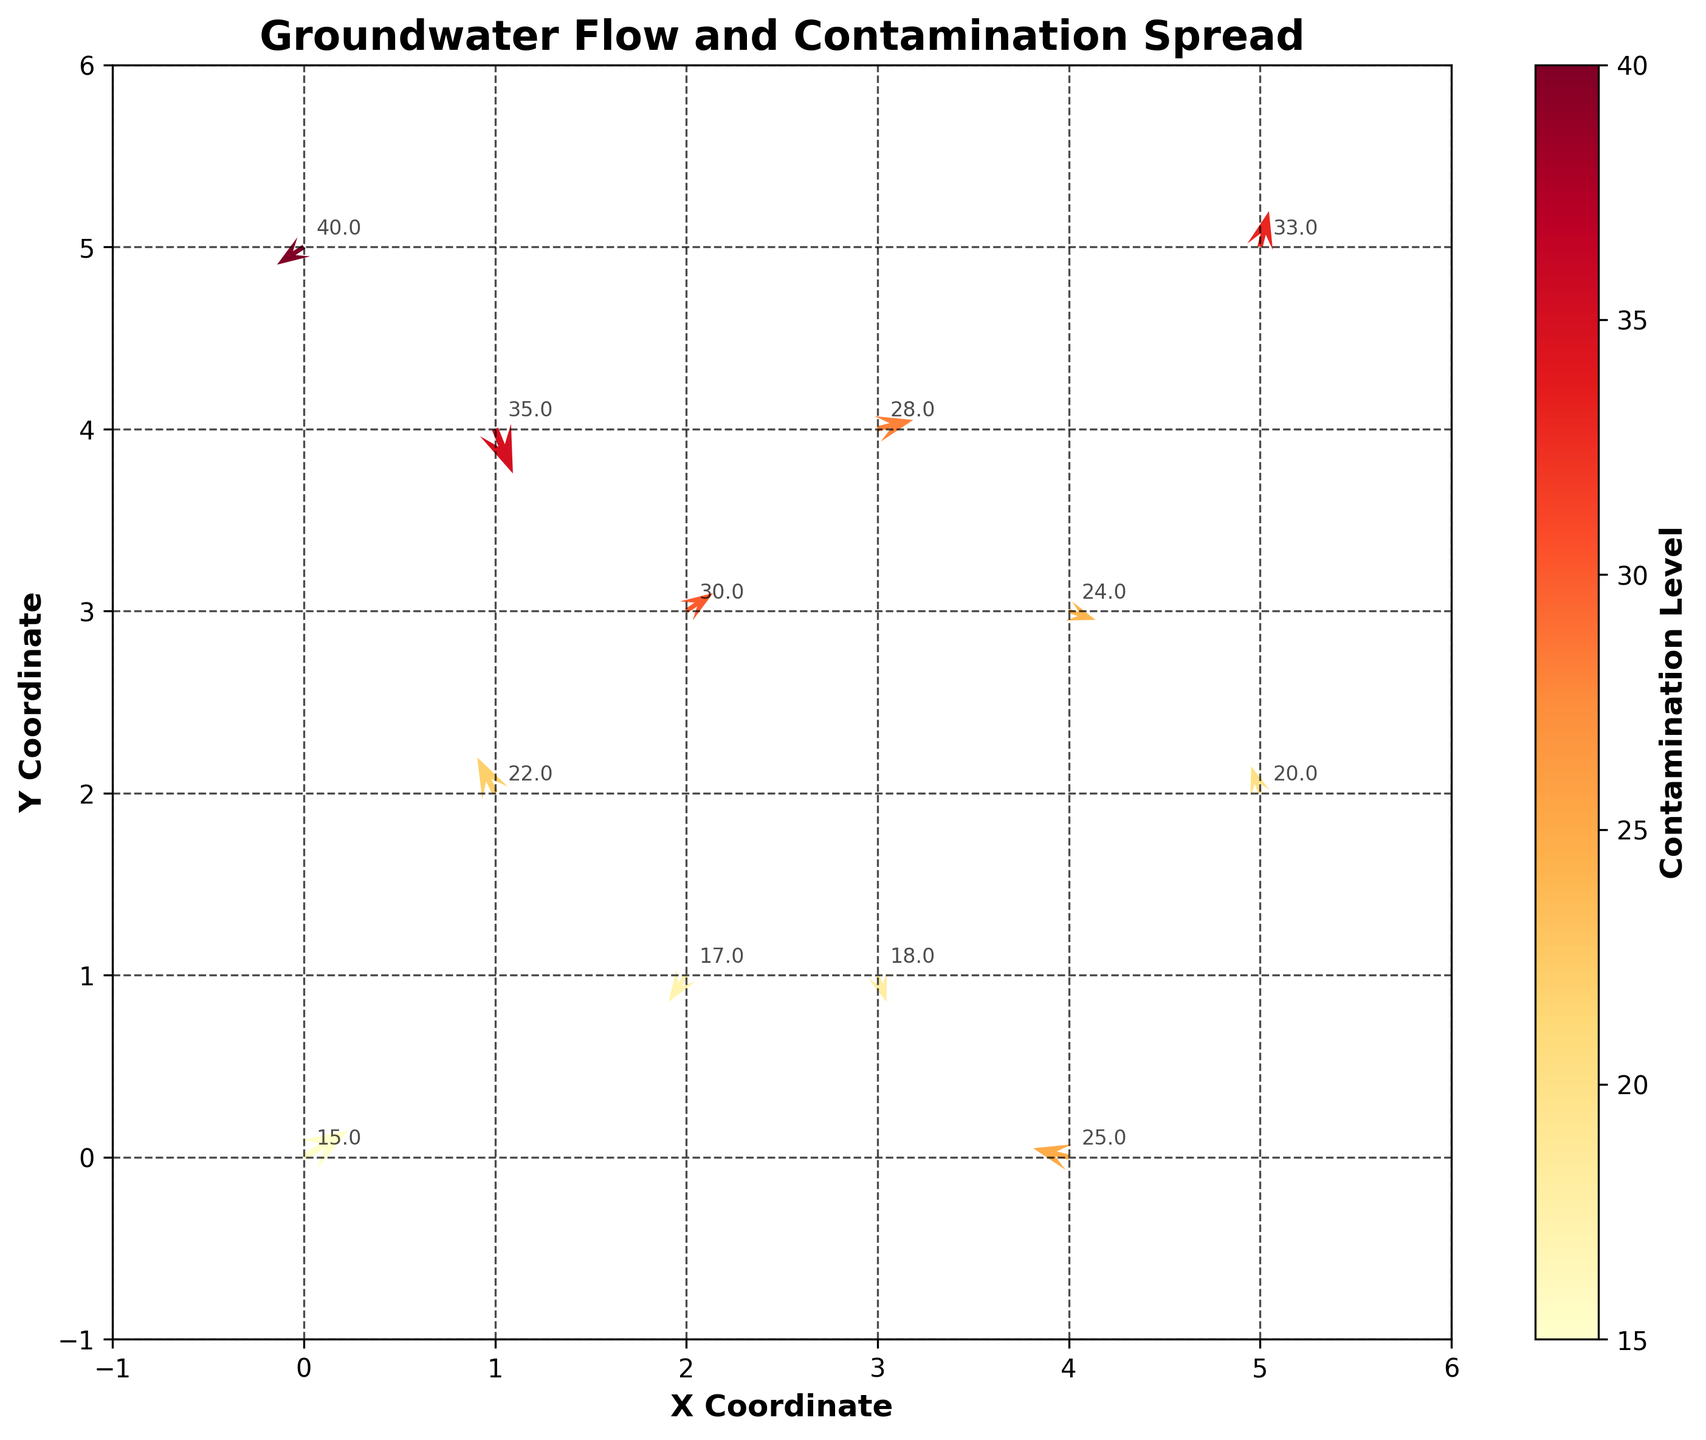What is the title of the figure? The title of the figure is located at the top and it reads 'Groundwater Flow and Contamination Spread'.
Answer: Groundwater Flow and Contamination Spread How many arrows are depicted in the plot? By counting the number of arrowheads or vectors in the quiver plot, we can determine the total number.
Answer: 12 What is the range of contamination levels depicted by the color scale? The colorbar to the right of the plot shows the range of contamination levels presented in different colors. The range can be read from the colorbar.
Answer: 15 to 40 What are the coordinates of the point with the highest contamination level? By referring to the annotations next to the arrows, we can find that the highest contamination level is 40, located at coordinates (0, 5).
Answer: (0, 5) What is the direction of groundwater flow at the point (4,0)? Look at the arrow/vector located at (4,0) to determine its direction. The arrow points leftwards and upwards indicating a flow direction of approximately northwest.
Answer: Northwest Which point has the contamination level closest to the average contamination level of all points and what is it? First, calculate the average contamination level. Sum of contamination levels: 15+22+18+30+25+35+20+28+40+33+17+24 = 307. Average contamination level is 307/12 ≈ 25.6. We can see that the point with the contamination level of 25 is closest to the average. It is located at coordinates (4,0).
Answer: (4,0) with 25 What is the difference in contamination level between the point at (0,0) and the point at (1,4)? Refer to the contamination levels at these coordinates: (0,0) has 15, and (1,4) has 35. The difference is 35 - 15.
Answer: 20 Which direction has the highest contamination flow and at which coordinates is it found? The highest contamination flow is identified as 40. Check the direction of the arrow at (0, 5), which points south-west.
Answer: Southwest at (0, 5) Find the point where contamination level is increasing but flow direction is downwards? For this, look for arrows pointing downwards with contamination levels higher than the previous one in the path. The point (1,4) has contamination level 35 and the flow direction is downwards.
Answer: (1, 4) How many points have a positive East-West (u) flow component? Positive East-West flow indicates the 'u' value is positive. Points with positive 'u' values are at (0,0), (2,3), (1,4), and (3,4). Count these points.
Answer: 4 